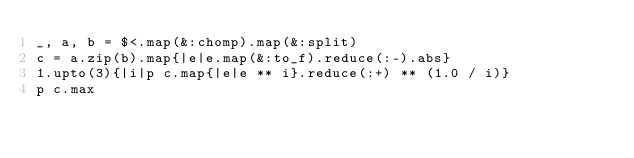Convert code to text. <code><loc_0><loc_0><loc_500><loc_500><_C#_>_, a, b = $<.map(&:chomp).map(&:split)
c = a.zip(b).map{|e|e.map(&:to_f).reduce(:-).abs}
1.upto(3){|i|p c.map{|e|e ** i}.reduce(:+) ** (1.0 / i)}
p c.max</code> 